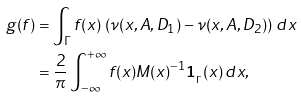Convert formula to latex. <formula><loc_0><loc_0><loc_500><loc_500>g ( f ) & = \int _ { \Gamma } f ( x ) \, \left ( \nu ( x , A , D _ { 1 } ) - \nu ( x , A , D _ { 2 } ) \right ) \, d x \\ & = \frac { 2 } { \pi } \int _ { - \infty } ^ { + \infty } f ( x ) M ( x ) ^ { - 1 } { \mathbf 1 } _ { _ { \Gamma } } ( x ) \, d x ,</formula> 